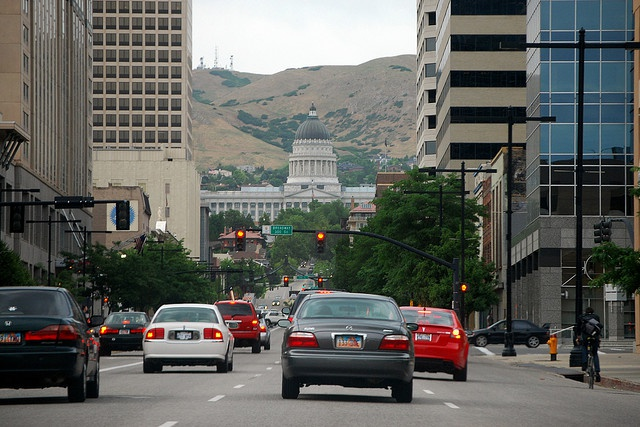Describe the objects in this image and their specific colors. I can see car in gray, black, and darkgray tones, car in gray, black, maroon, and darkblue tones, car in gray, darkgray, black, and lightgray tones, car in gray, black, brown, darkgray, and maroon tones, and car in gray, black, darkgray, and maroon tones in this image. 